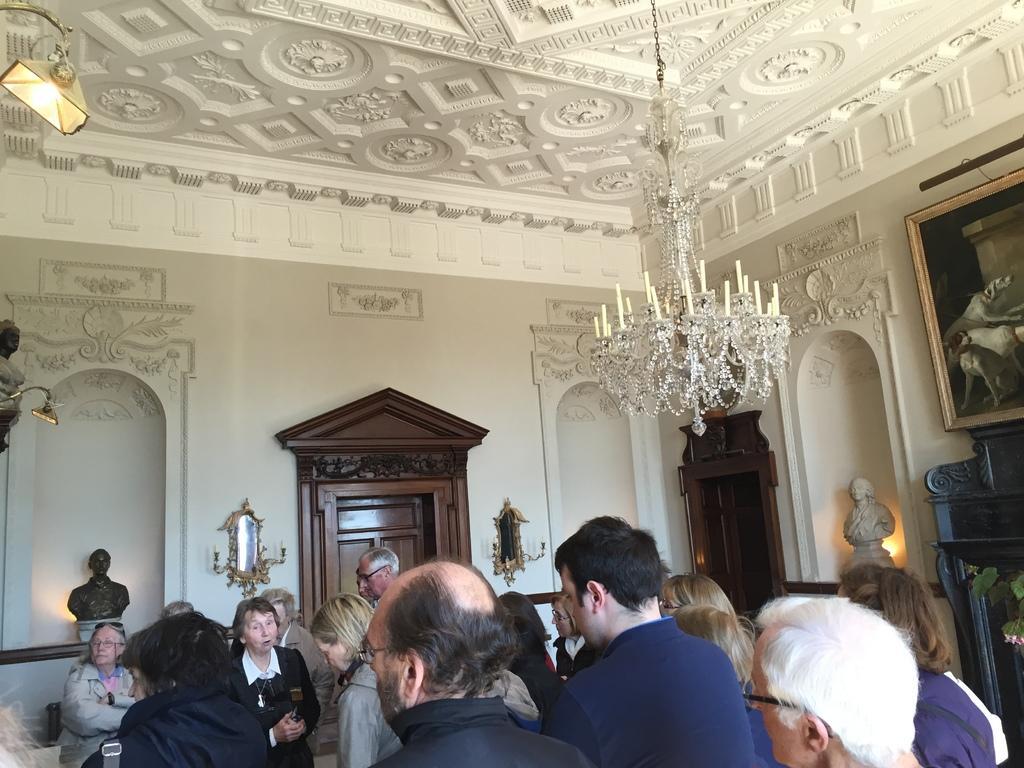Can you describe this image briefly? In the picture we can see some people are standing and some people are standing and facing them and in the background, we can see a wall with some designs and sculptures and a door which is made up of wood and to the ceiling we can see the light and to the wall we can also see a photo frame with a painting in it. 